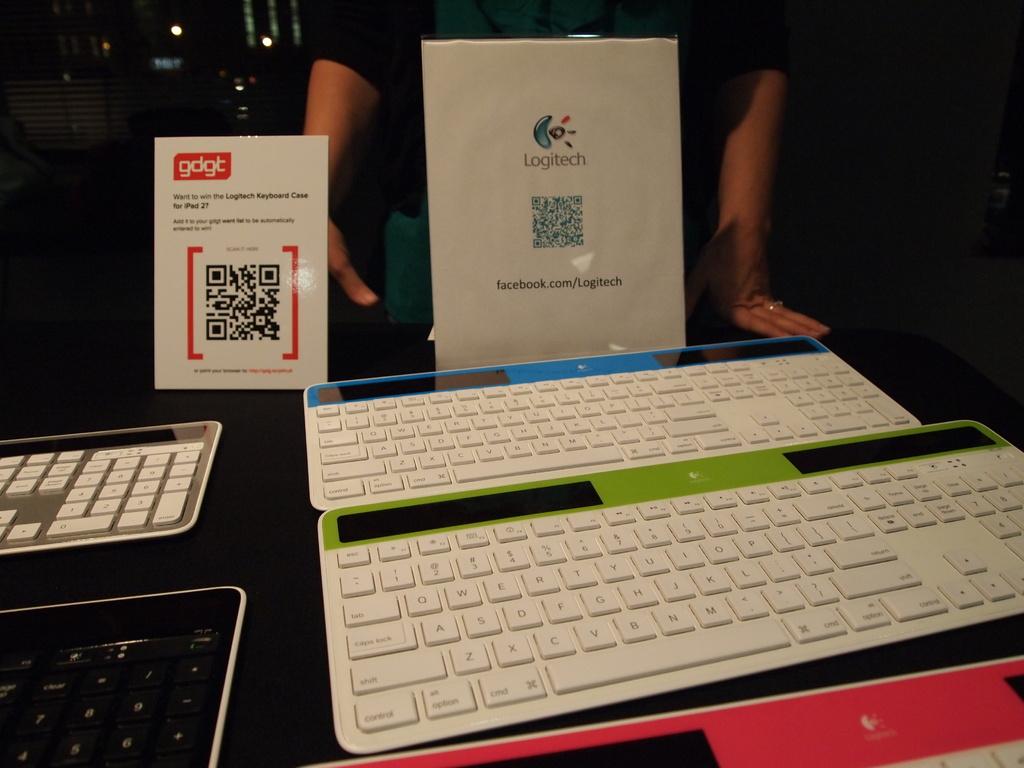What brand are these keyboards?
Offer a very short reply. Logitech. What is the name of the code on the sign?
Your answer should be compact. Gdgt. 